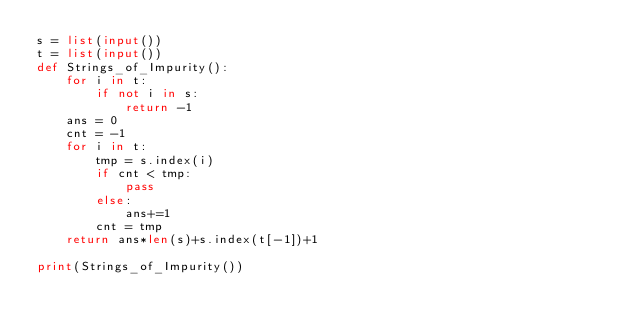<code> <loc_0><loc_0><loc_500><loc_500><_Python_>s = list(input())
t = list(input())
def Strings_of_Impurity():
    for i in t:
        if not i in s:
            return -1
    ans = 0
    cnt = -1
    for i in t:
        tmp = s.index(i)
        if cnt < tmp:
            pass
        else:
            ans+=1
        cnt = tmp
    return ans*len(s)+s.index(t[-1])+1

print(Strings_of_Impurity())</code> 